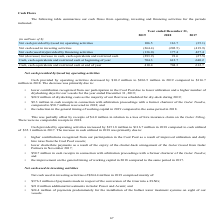From Golar Lng's financial document, What are the different components of cash flows? The document contains multiple relevant values: Net cash provided by/(used in) operating activities, Net cash used in investing activities, Net cash (used in)/provided by financing activities, Net (decrease) increase in cash, cash equivalents and restricted cash. From the document: "(used in) operating activities 106.5 116.7 (35.1) Net cash used in investing activities (264.4) (202.5) (419.9) Net cash (used in)/provided by financi..." Also, What was the amount of dividends received from Golar Partners in 2018? Based on the financial document, the answer is $33.2 million. Also, What accounted for the higher contributions from the participation in Cool Pool? Improved utilization and daily hire rates from the Cool Pool vessels. The document states: "our participation in the Cool Pool as a result of improved utilization and daily hire rates from the Cool Pool vessels;..." Additionally, In which year was the net cash provided by/(used in) operating activities the highest? According to the financial document, 2018. The relevant text states: "Year ended December 31, 2019 2018 2017 (in millions of $) Net cash provided by/(used in) operating activities 106.5 116.7 (35.1) Net..." Also, can you calculate: What was the change in cash, cash equivalents and restricted cash at beginning of year from 2018 to 2019? Based on the calculation: 704.3 - 612.7 , the result is 91.6 (in millions). This is based on the information: "ivalents and restricted cash at beginning of year 704.3 612.7 640.2 Cash, cash equivalents and restricted cash at end of year 410.4 704.3 612.7 ts and restricted cash at beginning of year 704.3 612.7 ..." The key data points involved are: 612.7, 704.3. Also, can you calculate: What was the percentage change in cash, cash equivalents and restricted cash at end of year from 2017 to 2018? To answer this question, I need to perform calculations using the financial data. The calculation is: (704.3 - 612.7)/612.7 , which equals 14.95 (percentage). This is based on the information: "ivalents and restricted cash at beginning of year 704.3 612.7 640.2 Cash, cash equivalents and restricted cash at end of year 410.4 704.3 612.7 ts and restricted cash at beginning of year 704.3 612.7 ..." The key data points involved are: 612.7, 704.3. 